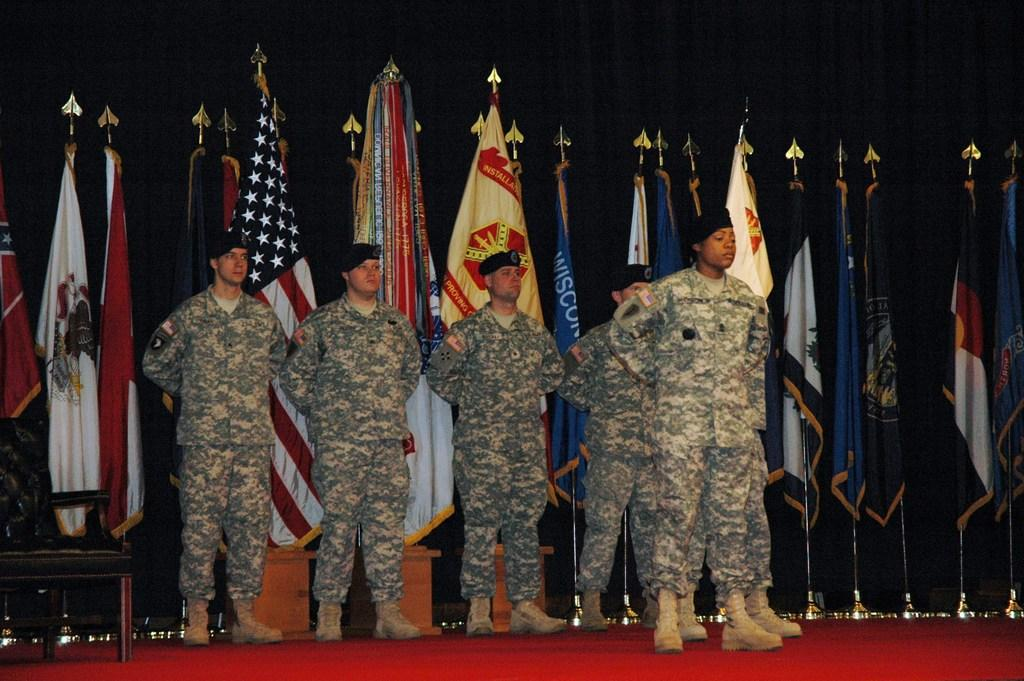How many people are in the image? There is a group of people in the image. What are the people doing in the image? The people are standing on the floor. What can be seen in the image besides the people? There are flags and a wall in the image. What is placed on a table in the image? There is an object placed on a table in the image. What type of chess move is being made by the person in the image? There is no chess game or chess pieces present in the image, so it is not possible to determine any chess moves. 